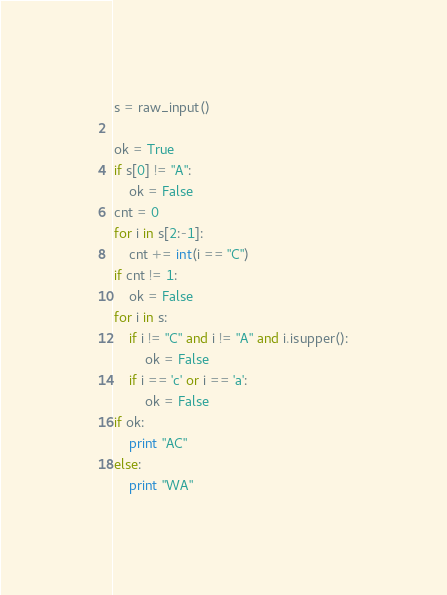Convert code to text. <code><loc_0><loc_0><loc_500><loc_500><_Python_>s = raw_input()

ok = True
if s[0] != "A":
    ok = False
cnt = 0
for i in s[2:-1]:
    cnt += int(i == "C")
if cnt != 1:
    ok = False
for i in s:
    if i != "C" and i != "A" and i.isupper():
        ok = False
    if i == 'c' or i == 'a':
        ok = False
if ok:
    print "AC"
else:
    print "WA"
</code> 